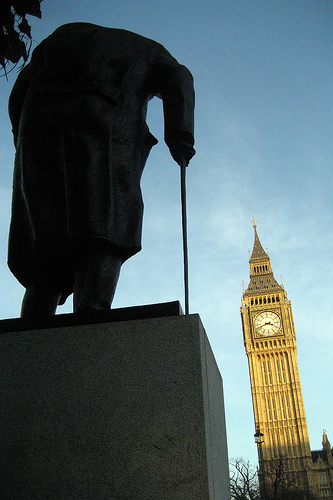<image>
Can you confirm if the big ben is under the statue? No. The big ben is not positioned under the statue. The vertical relationship between these objects is different. 